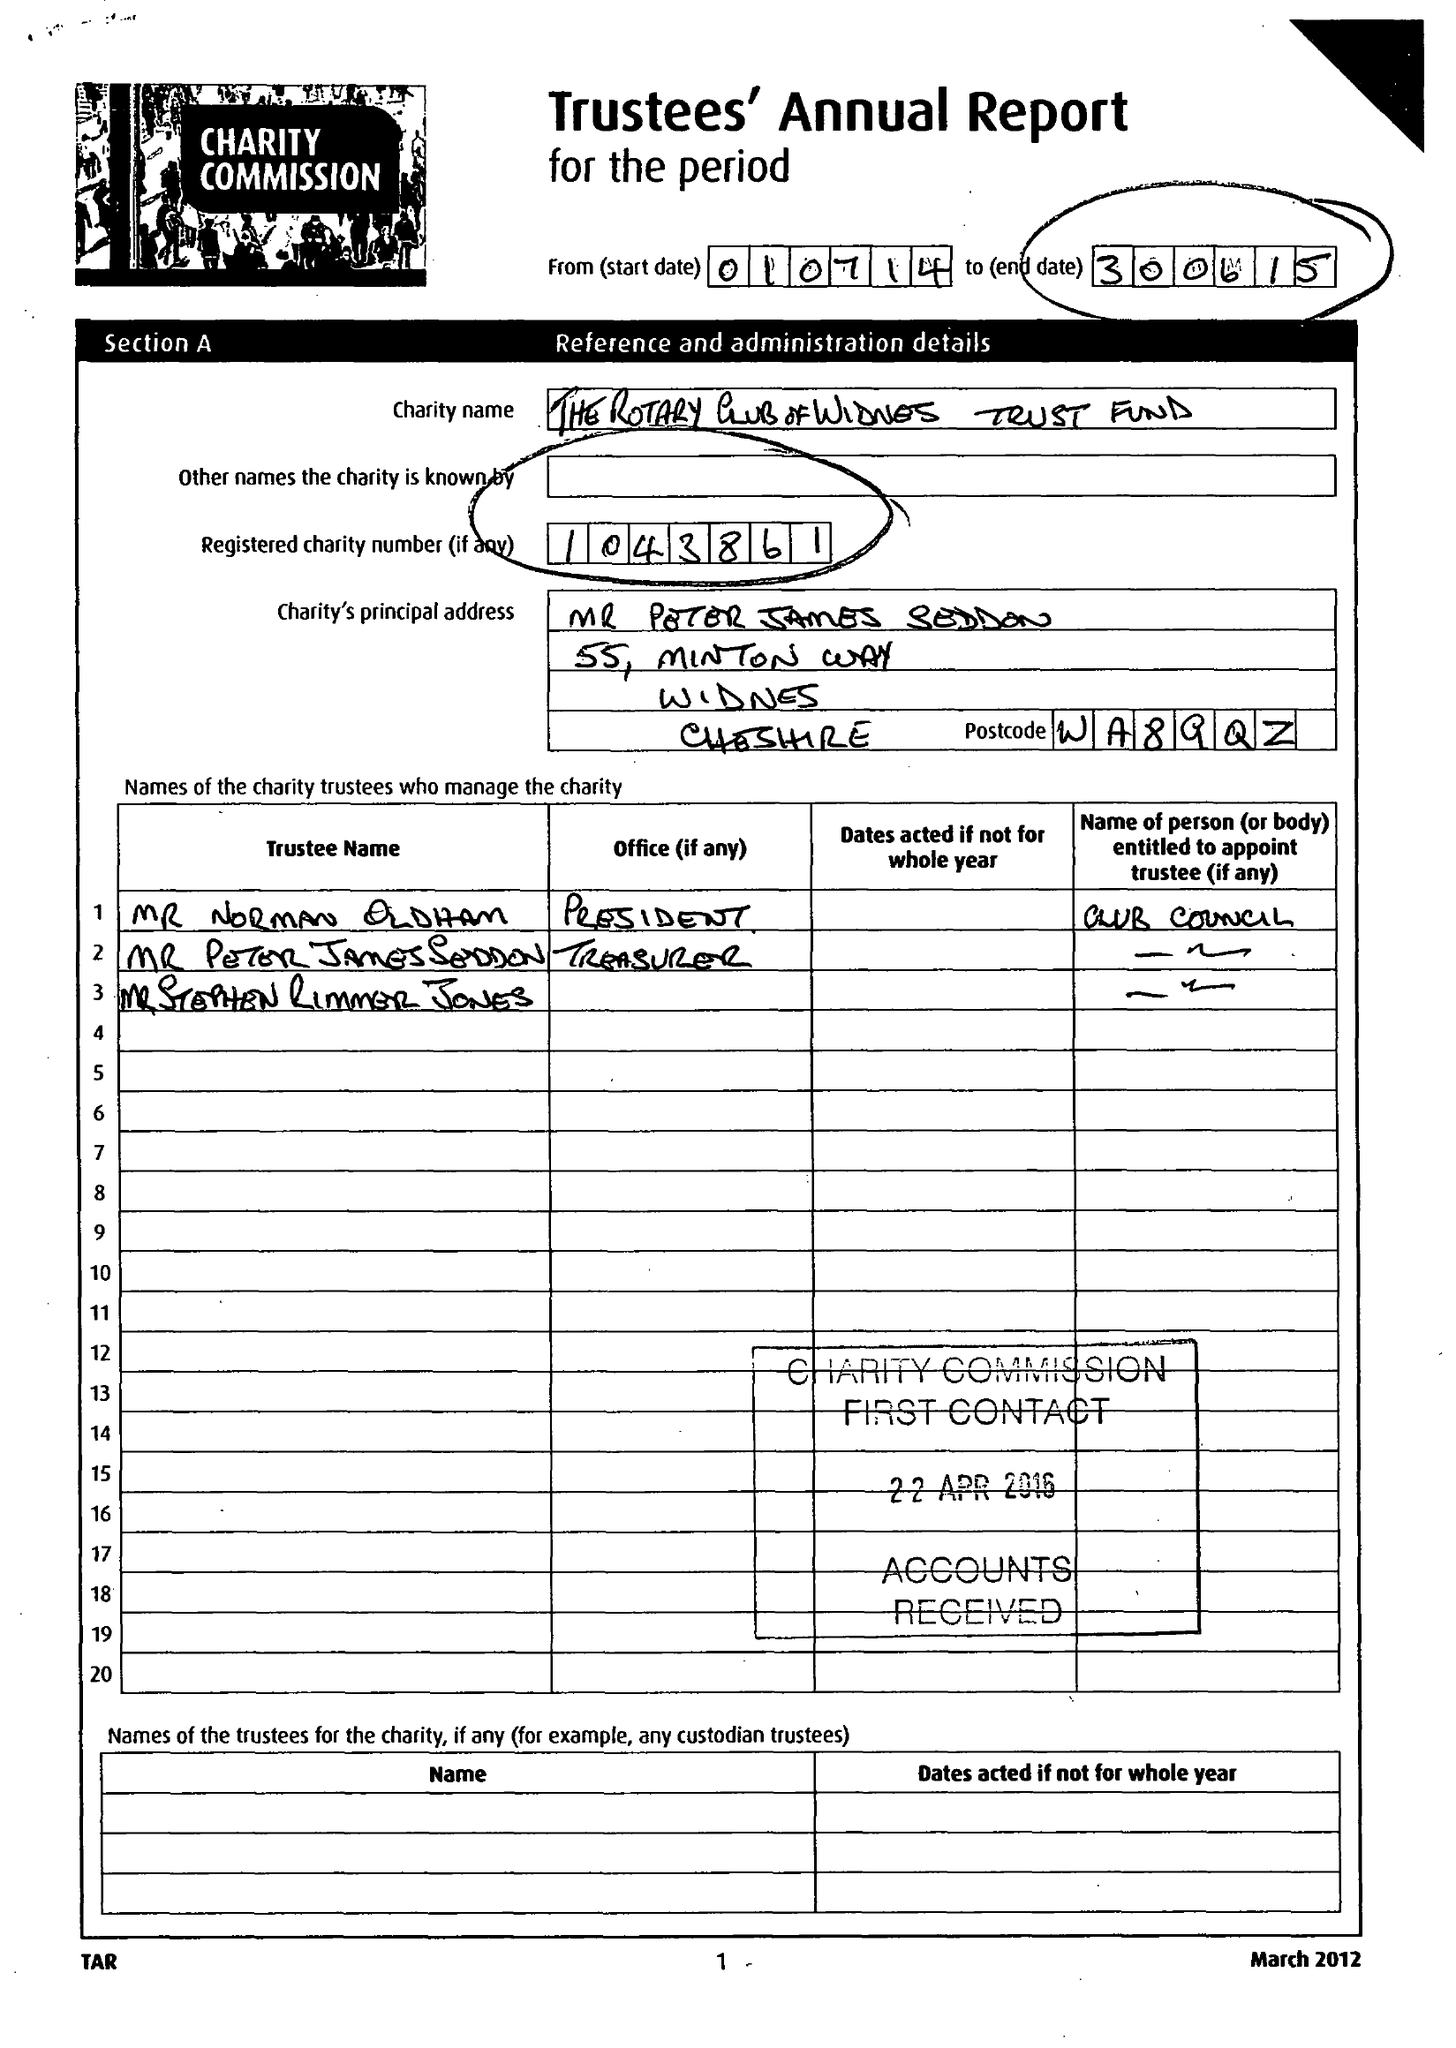What is the value for the spending_annually_in_british_pounds?
Answer the question using a single word or phrase. 59014.39 